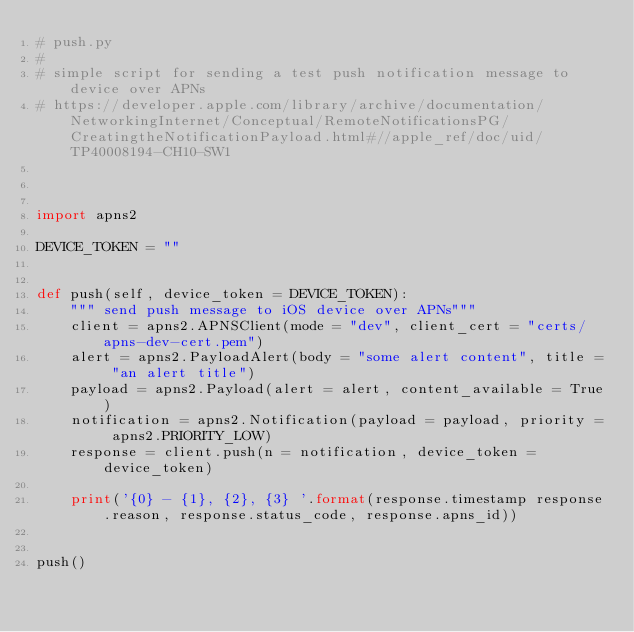<code> <loc_0><loc_0><loc_500><loc_500><_Python_># push.py 
#
# simple script for sending a test push notification message to device over APNs
# https://developer.apple.com/library/archive/documentation/NetworkingInternet/Conceptual/RemoteNotificationsPG/CreatingtheNotificationPayload.html#//apple_ref/doc/uid/TP40008194-CH10-SW1


 
import apns2

DEVICE_TOKEN = ""


def push(self, device_token = DEVICE_TOKEN):
    """ send push message to iOS device over APNs"""
    client = apns2.APNSClient(mode = "dev", client_cert = "certs/apns-dev-cert.pem")
    alert = apns2.PayloadAlert(body = "some alert content", title = "an alert title")
    payload = apns2.Payload(alert = alert, content_available = True)
    notification = apns2.Notification(payload = payload, priority = apns2.PRIORITY_LOW)
    response = client.push(n = notification, device_token = device_token)
    
    print('{0} - {1}, {2}, {3} '.format(response.timestamp response.reason, response.status_code, response.apns_id)) 


push()</code> 